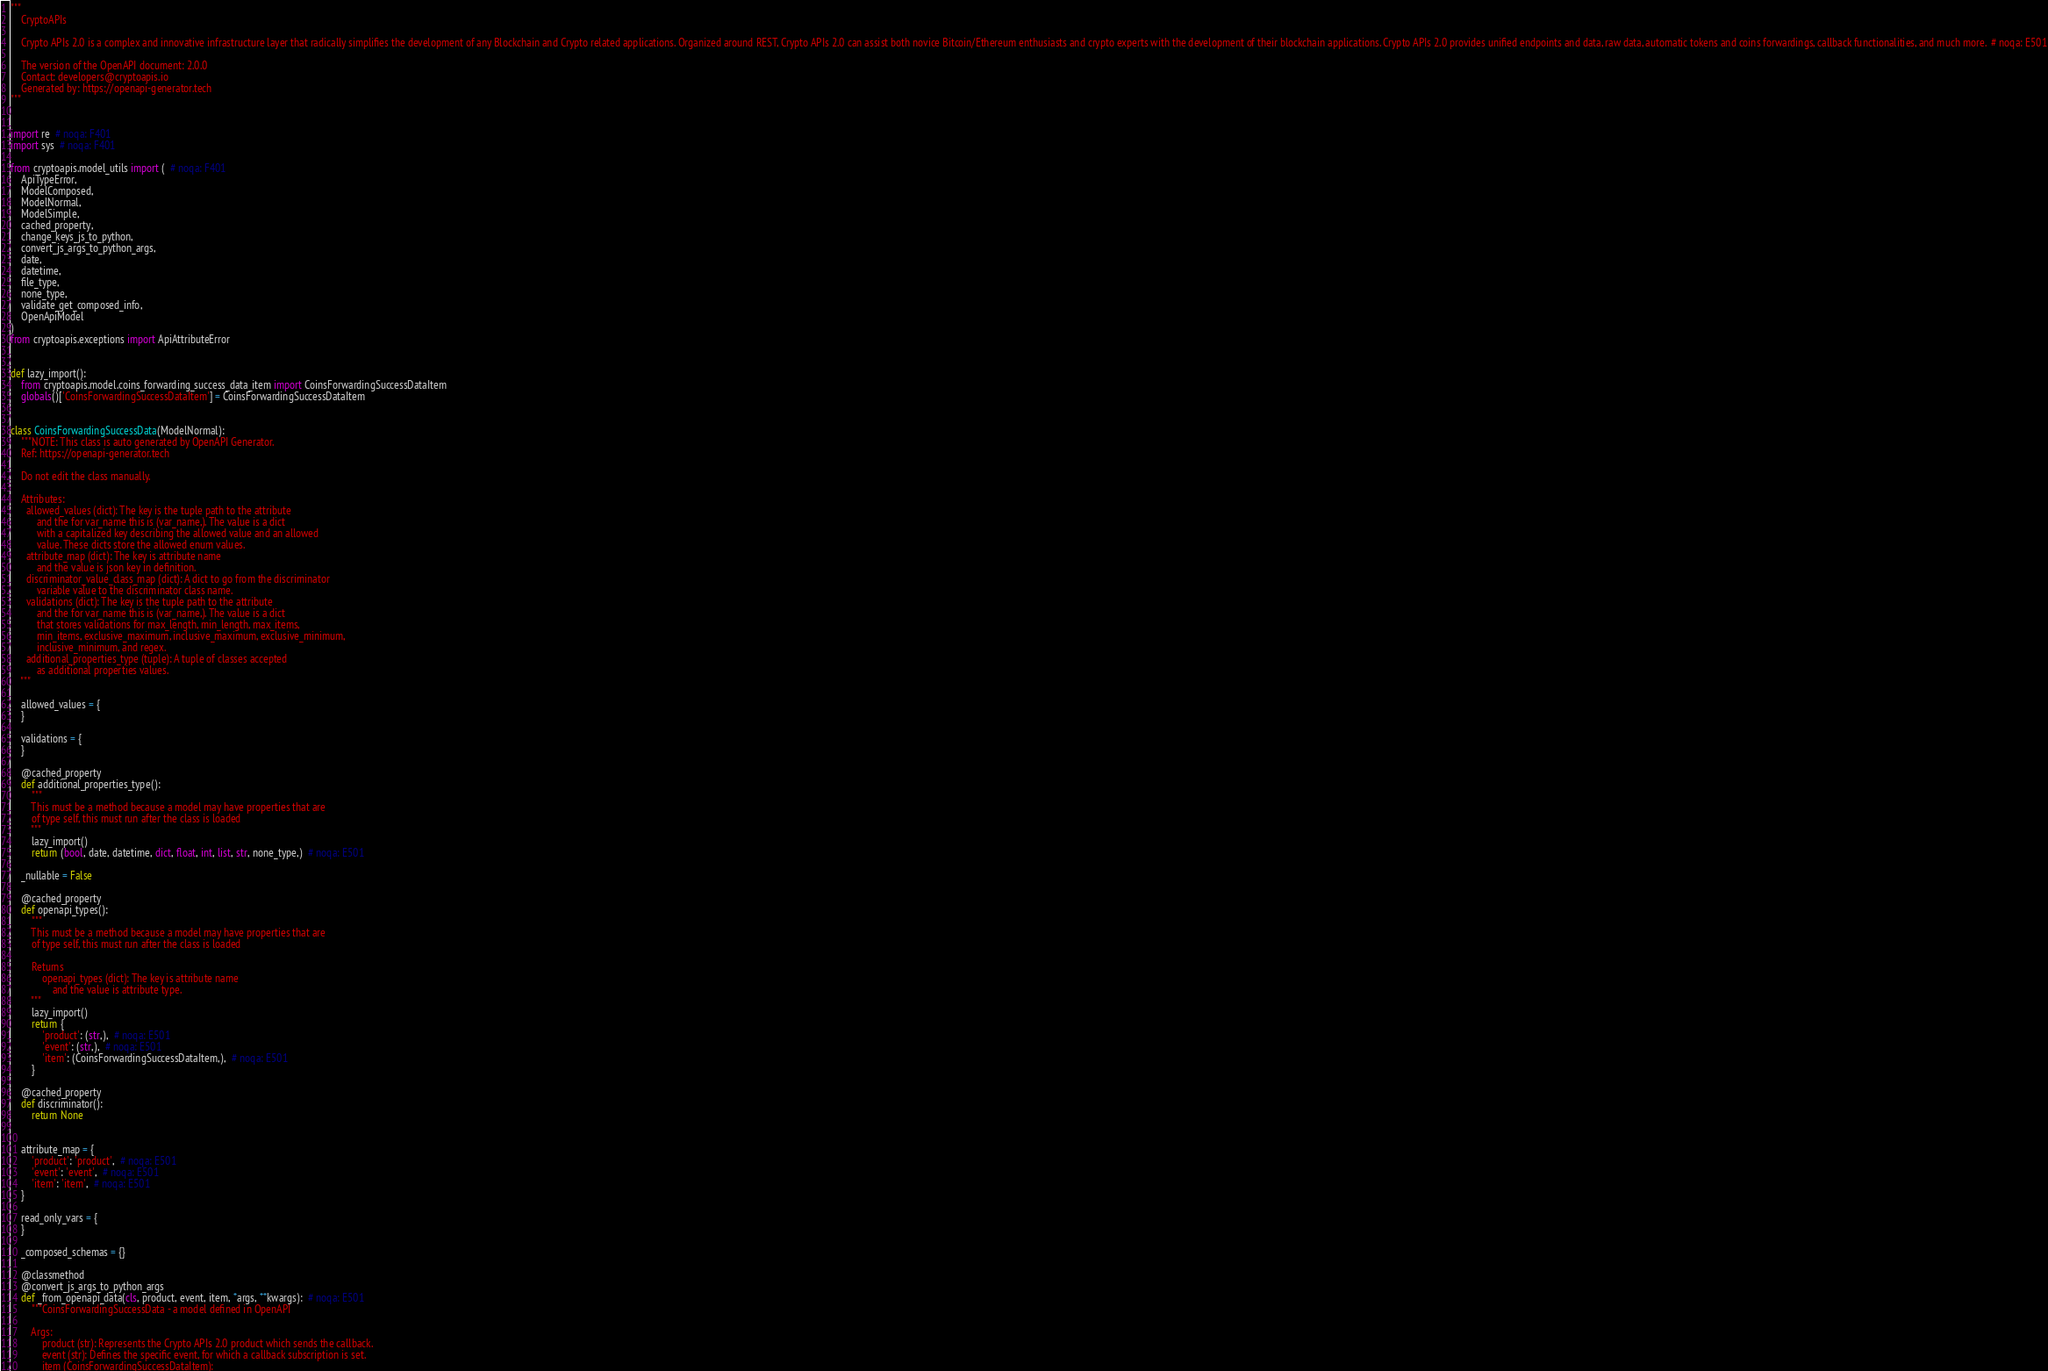<code> <loc_0><loc_0><loc_500><loc_500><_Python_>"""
    CryptoAPIs

    Crypto APIs 2.0 is a complex and innovative infrastructure layer that radically simplifies the development of any Blockchain and Crypto related applications. Organized around REST, Crypto APIs 2.0 can assist both novice Bitcoin/Ethereum enthusiasts and crypto experts with the development of their blockchain applications. Crypto APIs 2.0 provides unified endpoints and data, raw data, automatic tokens and coins forwardings, callback functionalities, and much more.  # noqa: E501

    The version of the OpenAPI document: 2.0.0
    Contact: developers@cryptoapis.io
    Generated by: https://openapi-generator.tech
"""


import re  # noqa: F401
import sys  # noqa: F401

from cryptoapis.model_utils import (  # noqa: F401
    ApiTypeError,
    ModelComposed,
    ModelNormal,
    ModelSimple,
    cached_property,
    change_keys_js_to_python,
    convert_js_args_to_python_args,
    date,
    datetime,
    file_type,
    none_type,
    validate_get_composed_info,
    OpenApiModel
)
from cryptoapis.exceptions import ApiAttributeError


def lazy_import():
    from cryptoapis.model.coins_forwarding_success_data_item import CoinsForwardingSuccessDataItem
    globals()['CoinsForwardingSuccessDataItem'] = CoinsForwardingSuccessDataItem


class CoinsForwardingSuccessData(ModelNormal):
    """NOTE: This class is auto generated by OpenAPI Generator.
    Ref: https://openapi-generator.tech

    Do not edit the class manually.

    Attributes:
      allowed_values (dict): The key is the tuple path to the attribute
          and the for var_name this is (var_name,). The value is a dict
          with a capitalized key describing the allowed value and an allowed
          value. These dicts store the allowed enum values.
      attribute_map (dict): The key is attribute name
          and the value is json key in definition.
      discriminator_value_class_map (dict): A dict to go from the discriminator
          variable value to the discriminator class name.
      validations (dict): The key is the tuple path to the attribute
          and the for var_name this is (var_name,). The value is a dict
          that stores validations for max_length, min_length, max_items,
          min_items, exclusive_maximum, inclusive_maximum, exclusive_minimum,
          inclusive_minimum, and regex.
      additional_properties_type (tuple): A tuple of classes accepted
          as additional properties values.
    """

    allowed_values = {
    }

    validations = {
    }

    @cached_property
    def additional_properties_type():
        """
        This must be a method because a model may have properties that are
        of type self, this must run after the class is loaded
        """
        lazy_import()
        return (bool, date, datetime, dict, float, int, list, str, none_type,)  # noqa: E501

    _nullable = False

    @cached_property
    def openapi_types():
        """
        This must be a method because a model may have properties that are
        of type self, this must run after the class is loaded

        Returns
            openapi_types (dict): The key is attribute name
                and the value is attribute type.
        """
        lazy_import()
        return {
            'product': (str,),  # noqa: E501
            'event': (str,),  # noqa: E501
            'item': (CoinsForwardingSuccessDataItem,),  # noqa: E501
        }

    @cached_property
    def discriminator():
        return None


    attribute_map = {
        'product': 'product',  # noqa: E501
        'event': 'event',  # noqa: E501
        'item': 'item',  # noqa: E501
    }

    read_only_vars = {
    }

    _composed_schemas = {}

    @classmethod
    @convert_js_args_to_python_args
    def _from_openapi_data(cls, product, event, item, *args, **kwargs):  # noqa: E501
        """CoinsForwardingSuccessData - a model defined in OpenAPI

        Args:
            product (str): Represents the Crypto APIs 2.0 product which sends the callback.
            event (str): Defines the specific event, for which a callback subscription is set.
            item (CoinsForwardingSuccessDataItem):
</code> 